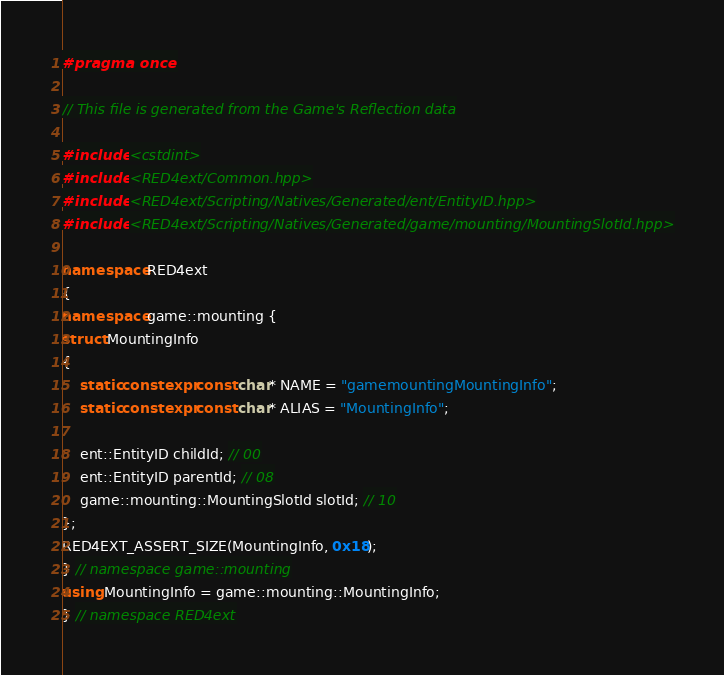<code> <loc_0><loc_0><loc_500><loc_500><_C++_>#pragma once

// This file is generated from the Game's Reflection data

#include <cstdint>
#include <RED4ext/Common.hpp>
#include <RED4ext/Scripting/Natives/Generated/ent/EntityID.hpp>
#include <RED4ext/Scripting/Natives/Generated/game/mounting/MountingSlotId.hpp>

namespace RED4ext
{
namespace game::mounting { 
struct MountingInfo
{
    static constexpr const char* NAME = "gamemountingMountingInfo";
    static constexpr const char* ALIAS = "MountingInfo";

    ent::EntityID childId; // 00
    ent::EntityID parentId; // 08
    game::mounting::MountingSlotId slotId; // 10
};
RED4EXT_ASSERT_SIZE(MountingInfo, 0x18);
} // namespace game::mounting
using MountingInfo = game::mounting::MountingInfo;
} // namespace RED4ext
</code> 